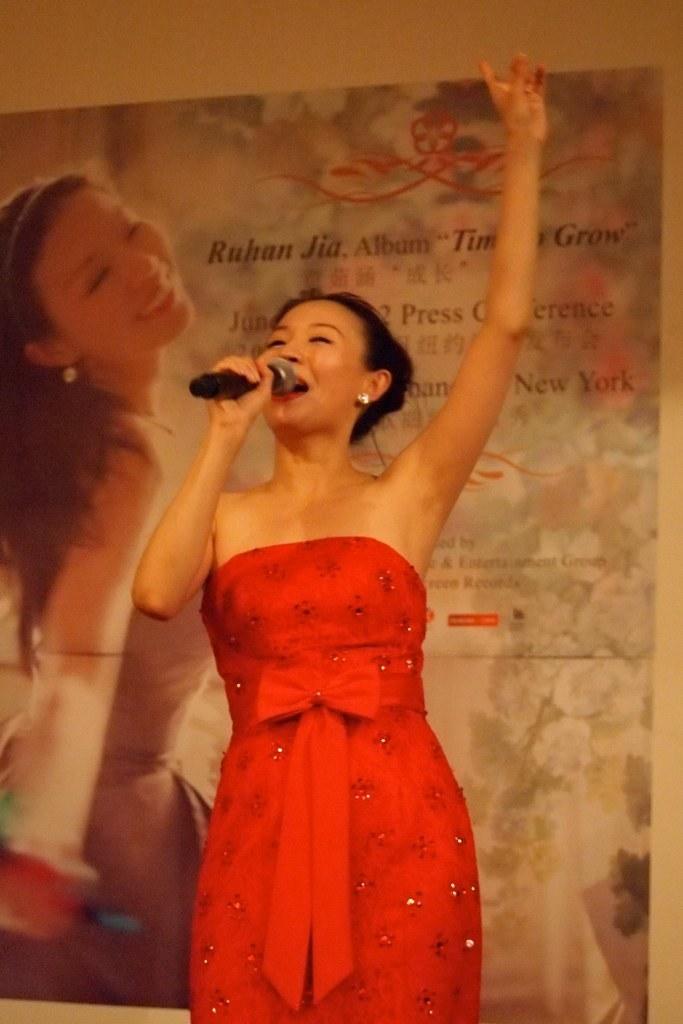Describe this image in one or two sentences. In this picture I can see a woman holding microphone. I can see the banner. 